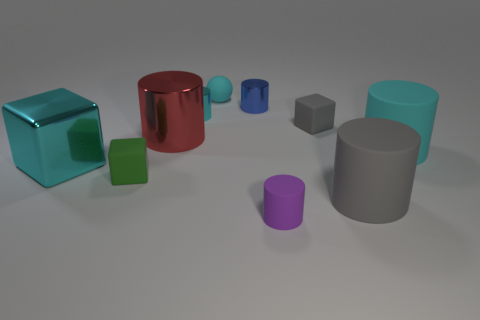What number of big cyan objects are there?
Your answer should be compact. 2. There is a rubber cube in front of the cyan matte object that is in front of the small gray object; is there a large red cylinder that is in front of it?
Your answer should be compact. No. What shape is the gray matte thing that is the same size as the green matte cube?
Give a very brief answer. Cube. How many other things are there of the same color as the large shiny block?
Provide a short and direct response. 3. What is the small purple thing made of?
Offer a terse response. Rubber. How many other things are there of the same material as the green object?
Provide a succinct answer. 5. What size is the block that is both on the right side of the large cyan cube and behind the tiny green thing?
Provide a succinct answer. Small. There is a rubber object behind the cyan shiny object behind the tiny gray rubber block; what is its shape?
Your response must be concise. Sphere. Is there any other thing that is the same shape as the purple rubber object?
Keep it short and to the point. Yes. Is the number of rubber things that are to the left of the large red metallic thing the same as the number of small blue rubber blocks?
Provide a succinct answer. No. 